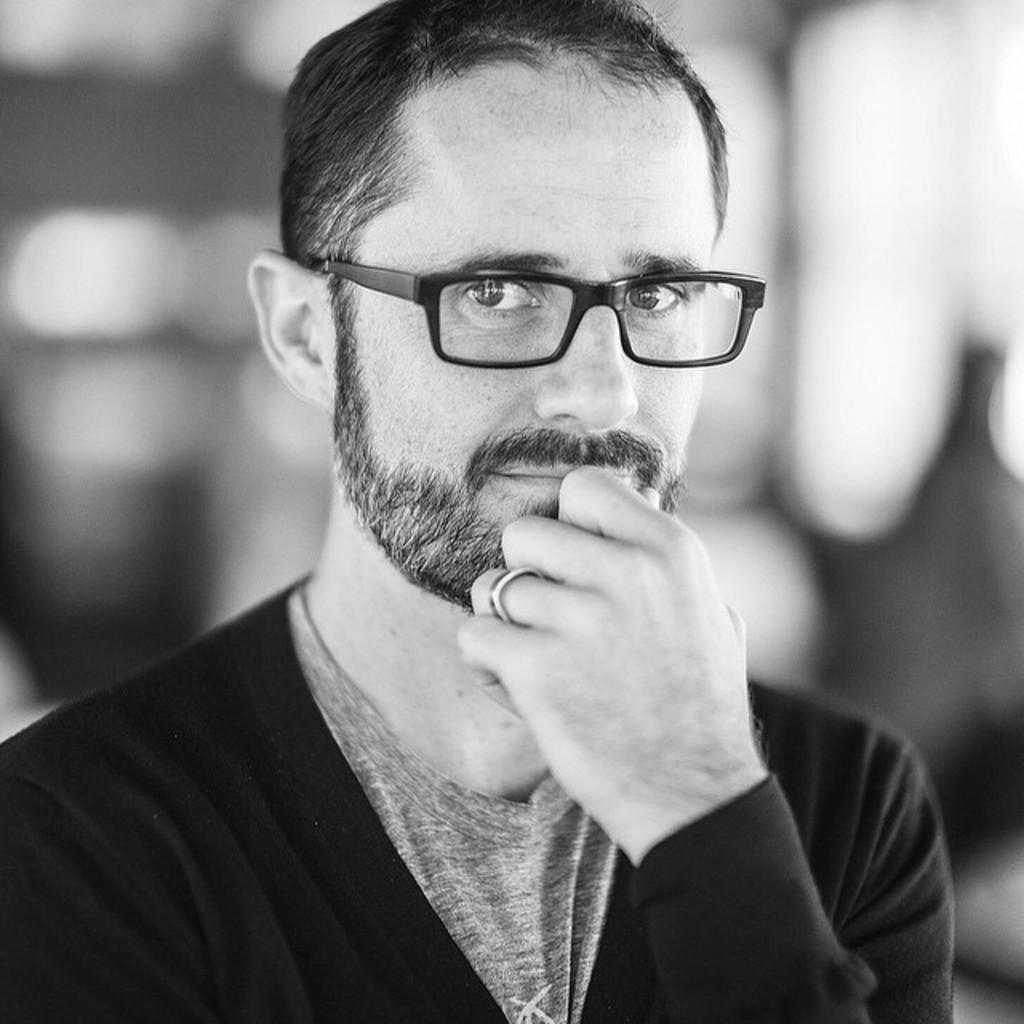What type of picture is in the image? The image contains a black and white picture. Can you describe the person in the picture? There is a person in the picture, and they are wearing a black dress and black-colored spectacles. What is the condition of the background in the picture? The background of the picture is blurry. What color is the paint on the straw in the image? There is no paint or straw present in the image. 